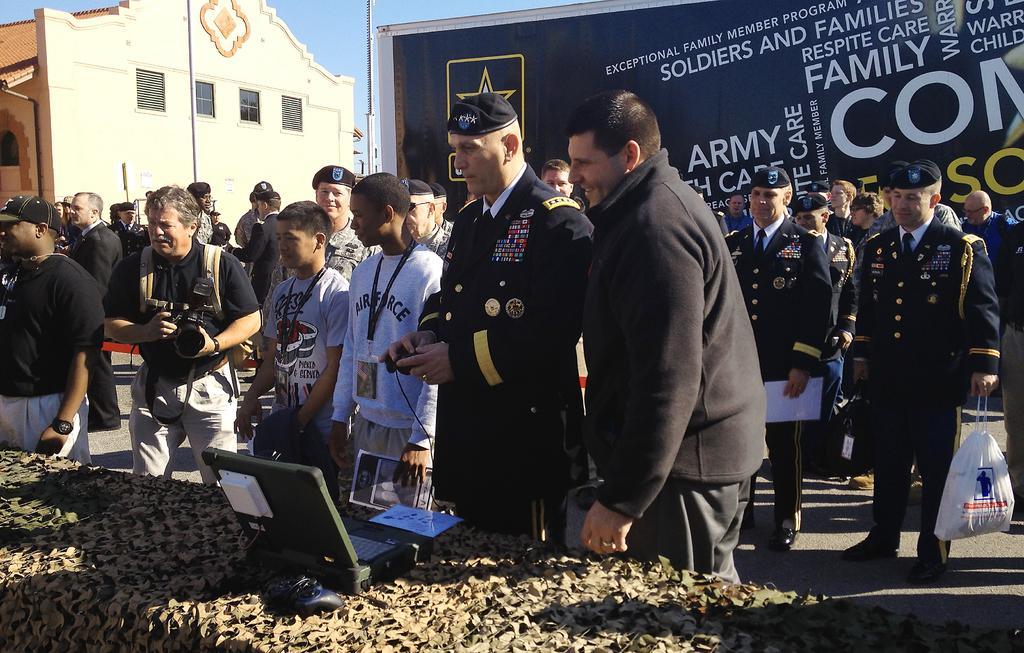Please provide a concise description of this image. In this image, we can see a crowd standing and wearing clothes. There is a laptop on the table which is at the bottom of the image. There is a building in the top left of the image. There is a banner at the top of the image. There is a person on the right side of the image holding a plastic bag with his hand. There is an another person on the left side of the image holding a camera with his hands. 